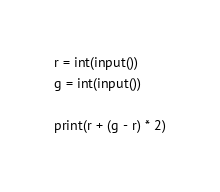<code> <loc_0><loc_0><loc_500><loc_500><_Python_>r = int(input())
g = int(input())

print(r + (g - r) * 2)
</code> 